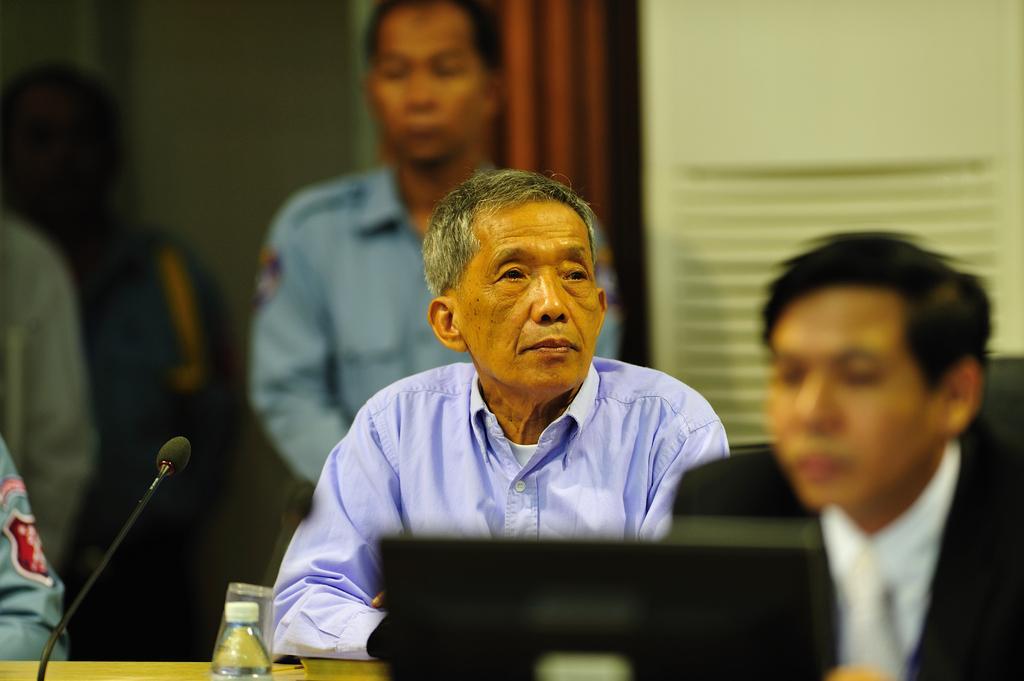Can you describe this image briefly? The image is inside the room. In the image there are two people sitting on chair in front of a table, on table we can see a laptop,water bottle and a microphone. In background there are group of people standing and a curtain which is in red color,air conditioner and a wall which is in cream color. 